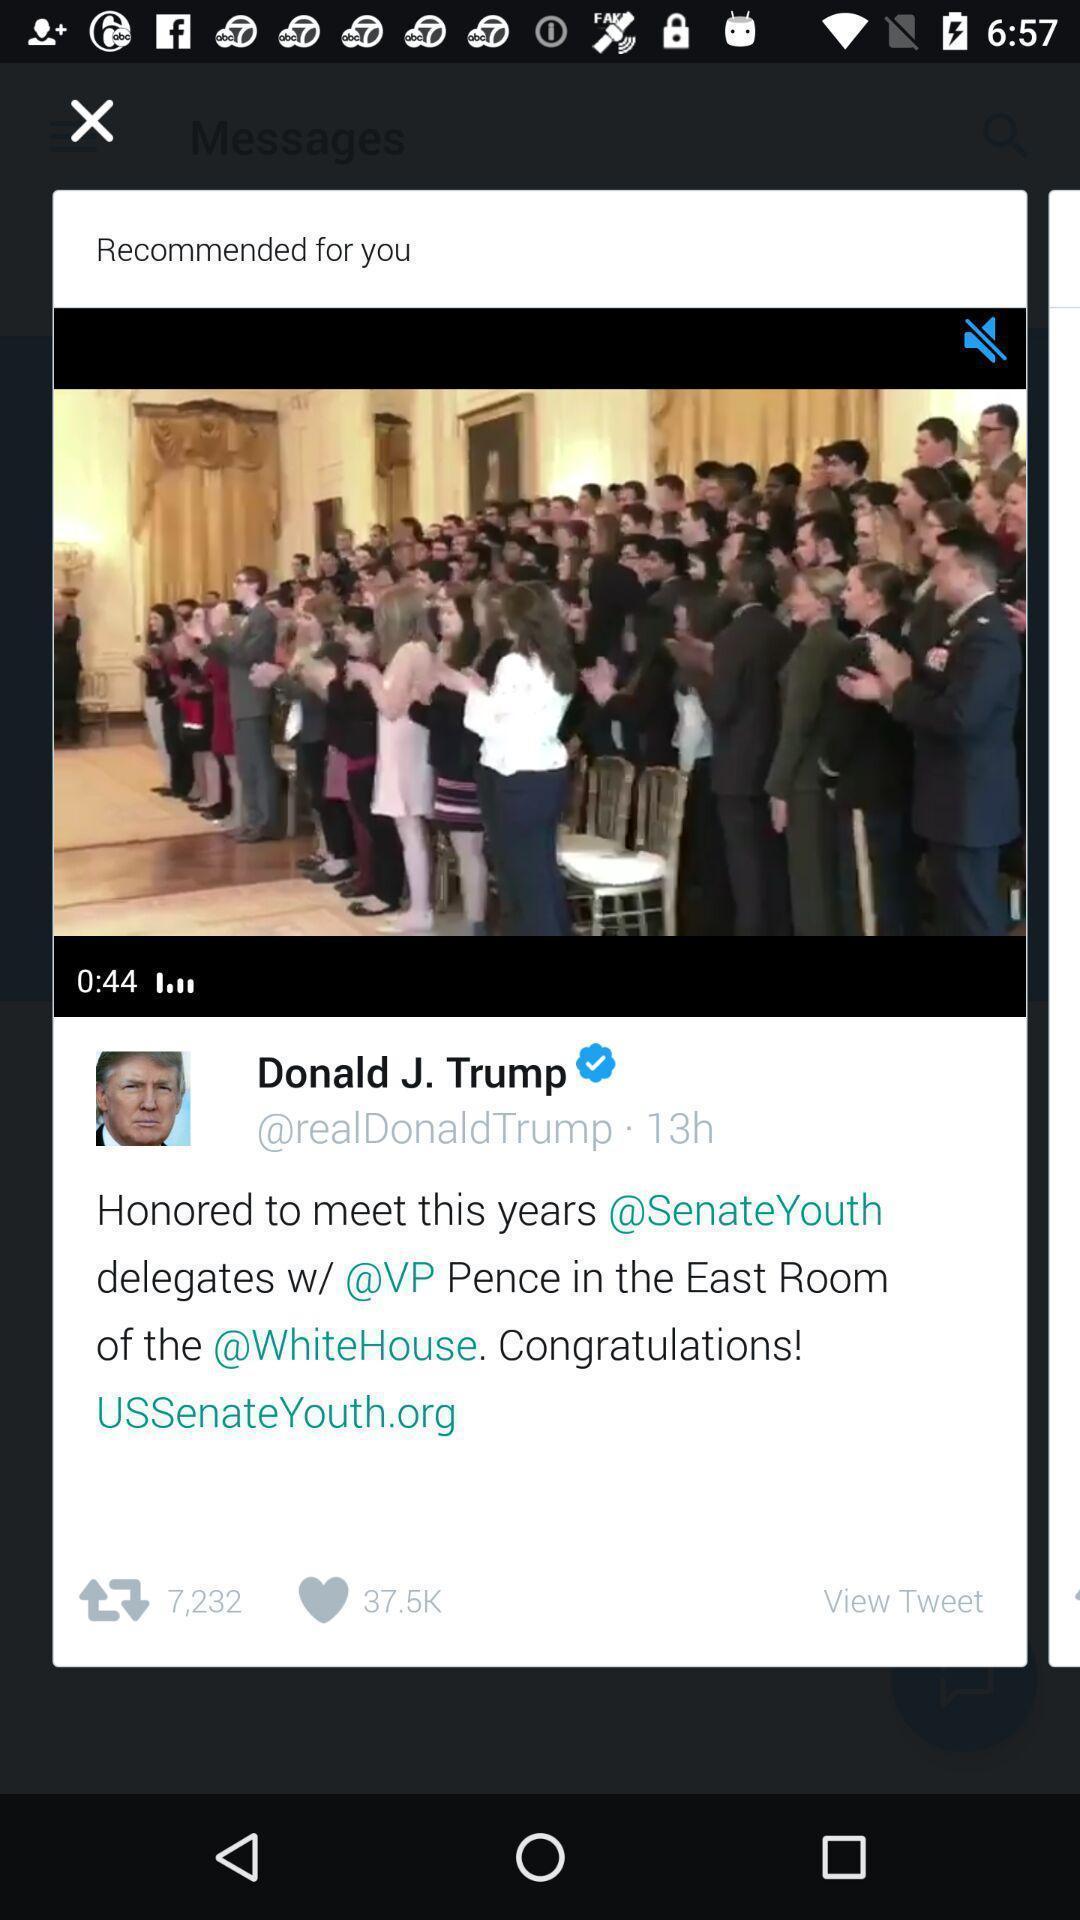What details can you identify in this image? Recommended video is mute mode. 